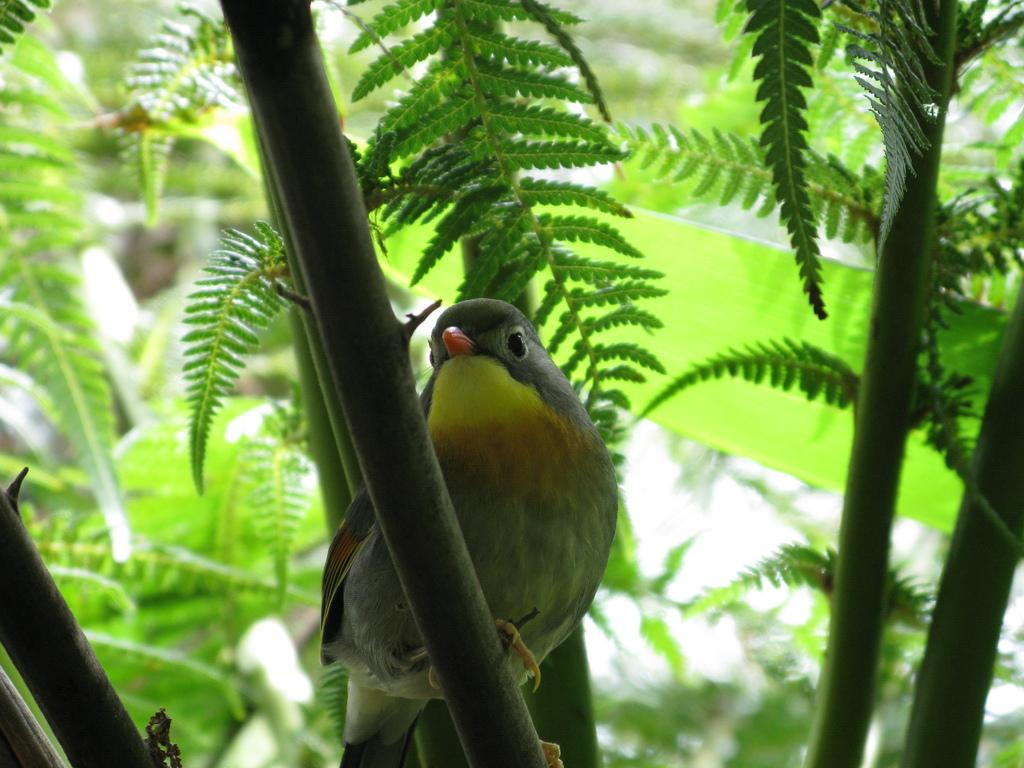What type of animal is present in the image? There is a bird in the image. Where is the bird located in the image? The bird is sitting on a tree branch. What type of straw is the bird using to build its nest in the image? There is no nest or straw present in the image; the bird is simply sitting on a tree branch. What type of flower can be seen growing near the bird in the image? There is no flower present in the image; the bird is sitting on a tree branch. 